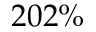<formula> <loc_0><loc_0><loc_500><loc_500>2 0 2 \%</formula> 